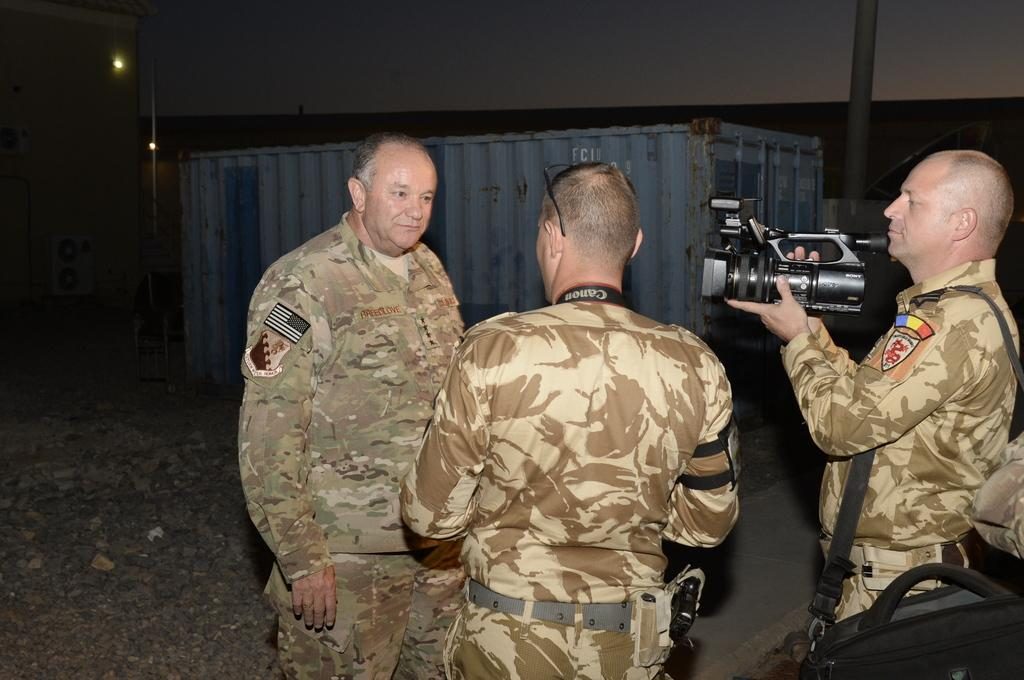How many men are in the image? There are three men in the image. What is one of the men doing in the image? One of the men is holding a camera. What is the man with the camera pointing at? The man with the camera is pointing to a person. What else is the man with the camera carrying? The man with the camera is carrying a bag. What can be seen in the background of the image? There is a box and a light in the background of the image. What type of fuel is being used by the watch in the image? There is no watch present in the image, and therefore no fuel can be associated with it. How many apples are visible in the image? There are no apples present in the image. 